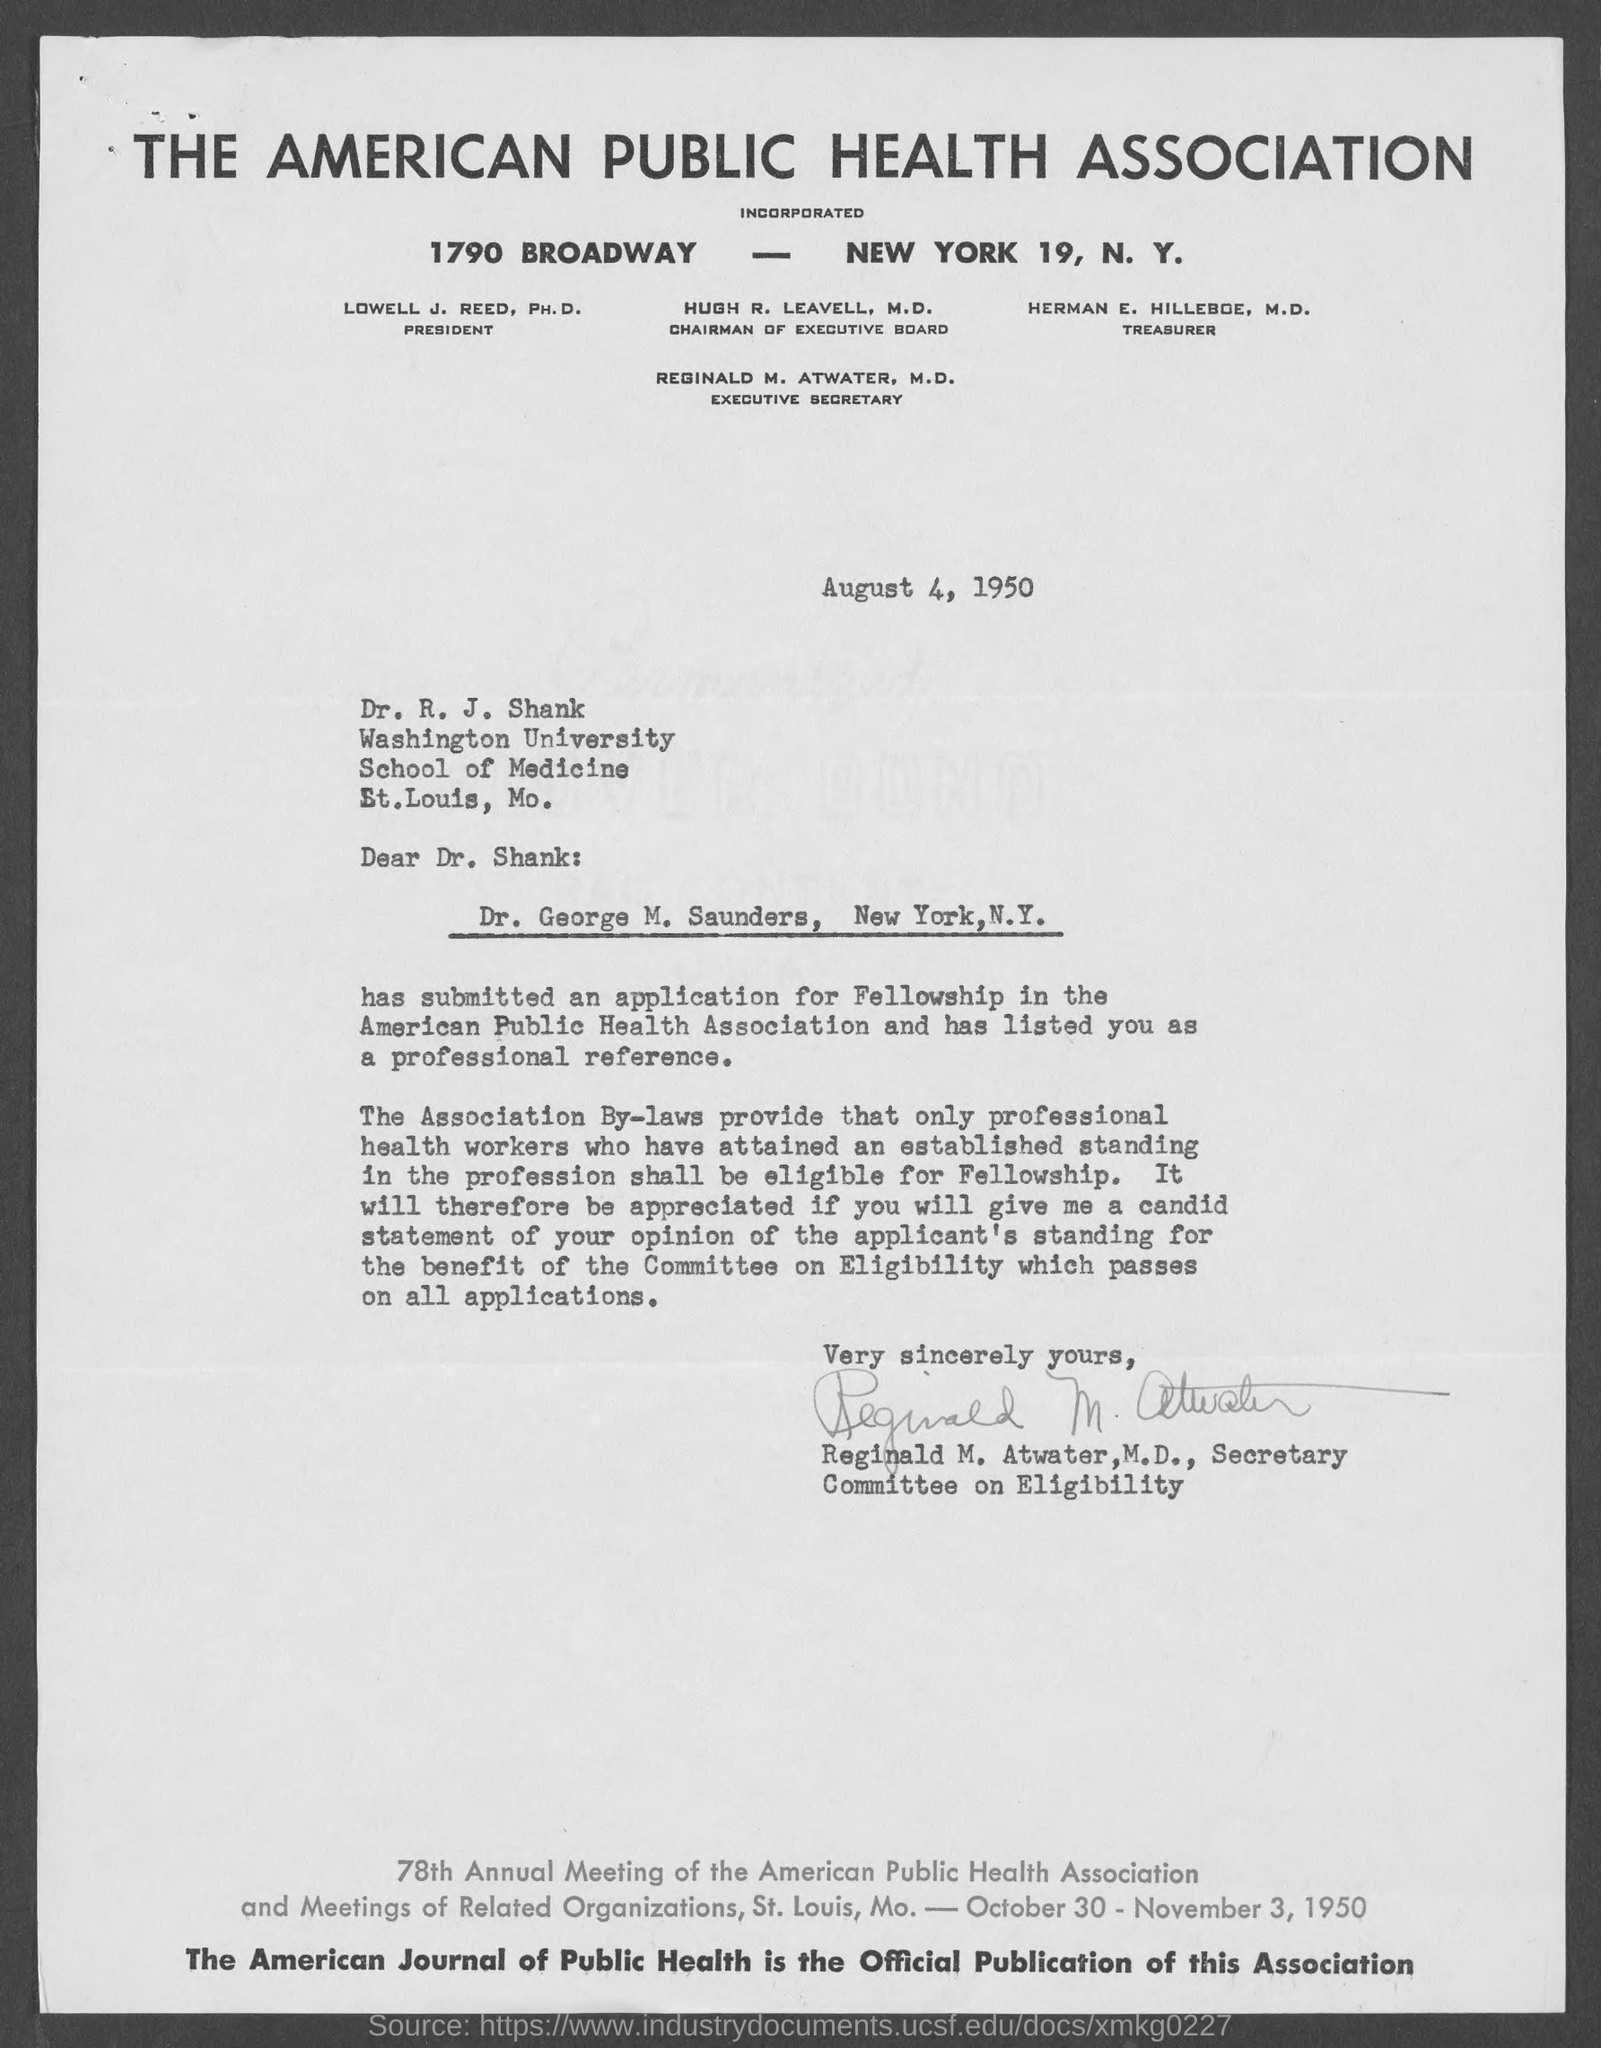Specify some key components in this picture. The American Public Health Association can be contacted at 1790 BROADWAY - NEW YORK 19, N.Y. Herman E. Hilleboe, M.D., is the current Treasurer of the American Public Health Association. The date on which the letter is written is August 4, 1950. Hugh R. Leavell, M.D., is the chairman of the Executive Board. The American Public Health Association is a health association that is known by its name. 